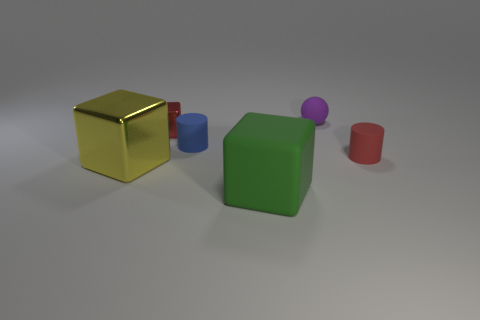How many rubber things are big purple objects or green things?
Your response must be concise. 1. There is a cylinder on the left side of the purple rubber thing; what color is it?
Offer a very short reply. Blue. The purple object that is the same size as the red matte cylinder is what shape?
Ensure brevity in your answer.  Sphere. There is a matte cube; does it have the same color as the block behind the blue cylinder?
Offer a terse response. No. What number of things are either metallic cubes that are behind the big yellow thing or small balls to the right of the small red cube?
Offer a terse response. 2. What material is the red cylinder that is the same size as the red metal cube?
Offer a terse response. Rubber. How many other objects are the same material as the yellow object?
Your answer should be very brief. 1. There is a tiny red thing that is behind the blue cylinder; is it the same shape as the small red thing that is on the right side of the tiny red metallic block?
Provide a short and direct response. No. What is the color of the tiny matte cylinder that is right of the thing in front of the large thing that is behind the large matte cube?
Provide a succinct answer. Red. How many other things are there of the same color as the big matte block?
Offer a very short reply. 0. 